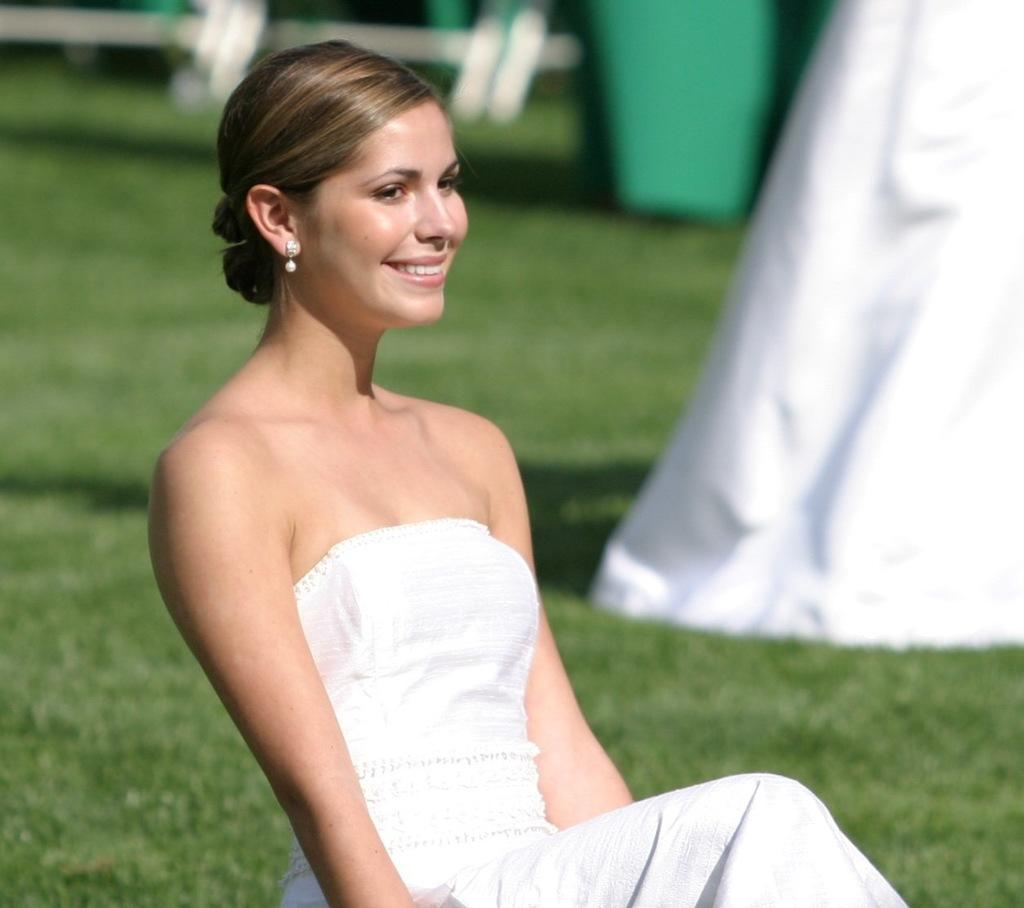Who is present in the image? There is a woman in the image. What is the woman wearing? The woman is wearing a white frock. What expression does the woman have? The woman is smiling. What type of jewelry is the woman wearing? The woman is wearing white earrings. What can be seen in the background of the woman? There is a lot of grass behind the woman. What type of scale can be seen in the image? There is no scale present in the image. What is the aftermath of the event depicted in the image? There is no event depicted in the image, so it's not possible to determine the aftermath. 